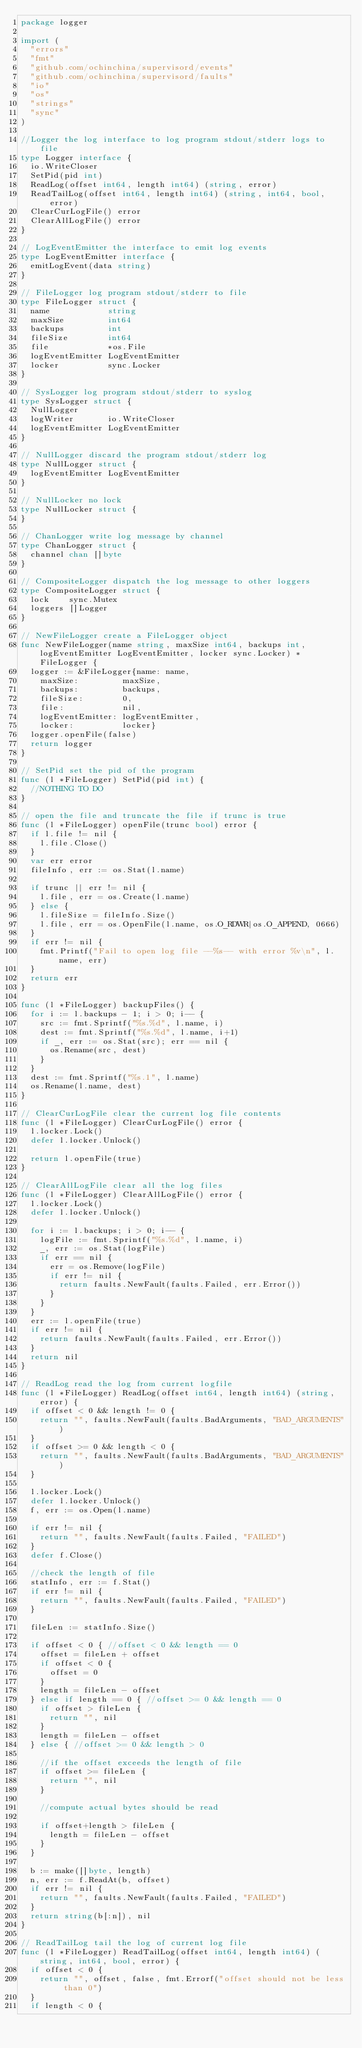Convert code to text. <code><loc_0><loc_0><loc_500><loc_500><_Go_>package logger

import (
	"errors"
	"fmt"
	"github.com/ochinchina/supervisord/events"
	"github.com/ochinchina/supervisord/faults"
	"io"
	"os"
	"strings"
	"sync"
)

//Logger the log interface to log program stdout/stderr logs to file
type Logger interface {
	io.WriteCloser
	SetPid(pid int)
	ReadLog(offset int64, length int64) (string, error)
	ReadTailLog(offset int64, length int64) (string, int64, bool, error)
	ClearCurLogFile() error
	ClearAllLogFile() error
}

// LogEventEmitter the interface to emit log events
type LogEventEmitter interface {
	emitLogEvent(data string)
}

// FileLogger log program stdout/stderr to file
type FileLogger struct {
	name            string
	maxSize         int64
	backups         int
	fileSize        int64
	file            *os.File
	logEventEmitter LogEventEmitter
	locker          sync.Locker
}

// SysLogger log program stdout/stderr to syslog
type SysLogger struct {
	NullLogger
	logWriter       io.WriteCloser
	logEventEmitter LogEventEmitter
}

// NullLogger discard the program stdout/stderr log
type NullLogger struct {
	logEventEmitter LogEventEmitter
}

// NullLocker no lock
type NullLocker struct {
}

// ChanLogger write log message by channel
type ChanLogger struct {
	channel chan []byte
}

// CompositeLogger dispatch the log message to other loggers
type CompositeLogger struct {
	lock    sync.Mutex
	loggers []Logger
}

// NewFileLogger create a FileLogger object
func NewFileLogger(name string, maxSize int64, backups int, logEventEmitter LogEventEmitter, locker sync.Locker) *FileLogger {
	logger := &FileLogger{name: name,
		maxSize:         maxSize,
		backups:         backups,
		fileSize:        0,
		file:            nil,
		logEventEmitter: logEventEmitter,
		locker:          locker}
	logger.openFile(false)
	return logger
}

// SetPid set the pid of the program
func (l *FileLogger) SetPid(pid int) {
	//NOTHING TO DO
}

// open the file and truncate the file if trunc is true
func (l *FileLogger) openFile(trunc bool) error {
	if l.file != nil {
		l.file.Close()
	}
	var err error
	fileInfo, err := os.Stat(l.name)

	if trunc || err != nil {
		l.file, err = os.Create(l.name)
	} else {
		l.fileSize = fileInfo.Size()
		l.file, err = os.OpenFile(l.name, os.O_RDWR|os.O_APPEND, 0666)
	}
	if err != nil {
		fmt.Printf("Fail to open log file --%s-- with error %v\n", l.name, err)
	}
	return err
}

func (l *FileLogger) backupFiles() {
	for i := l.backups - 1; i > 0; i-- {
		src := fmt.Sprintf("%s.%d", l.name, i)
		dest := fmt.Sprintf("%s.%d", l.name, i+1)
		if _, err := os.Stat(src); err == nil {
			os.Rename(src, dest)
		}
	}
	dest := fmt.Sprintf("%s.1", l.name)
	os.Rename(l.name, dest)
}

// ClearCurLogFile clear the current log file contents
func (l *FileLogger) ClearCurLogFile() error {
	l.locker.Lock()
	defer l.locker.Unlock()

	return l.openFile(true)
}

// ClearAllLogFile clear all the log files
func (l *FileLogger) ClearAllLogFile() error {
	l.locker.Lock()
	defer l.locker.Unlock()

	for i := l.backups; i > 0; i-- {
		logFile := fmt.Sprintf("%s.%d", l.name, i)
		_, err := os.Stat(logFile)
		if err == nil {
			err = os.Remove(logFile)
			if err != nil {
				return faults.NewFault(faults.Failed, err.Error())
			}
		}
	}
	err := l.openFile(true)
	if err != nil {
		return faults.NewFault(faults.Failed, err.Error())
	}
	return nil
}

// ReadLog read the log from current logfile
func (l *FileLogger) ReadLog(offset int64, length int64) (string, error) {
	if offset < 0 && length != 0 {
		return "", faults.NewFault(faults.BadArguments, "BAD_ARGUMENTS")
	}
	if offset >= 0 && length < 0 {
		return "", faults.NewFault(faults.BadArguments, "BAD_ARGUMENTS")
	}

	l.locker.Lock()
	defer l.locker.Unlock()
	f, err := os.Open(l.name)

	if err != nil {
		return "", faults.NewFault(faults.Failed, "FAILED")
	}
	defer f.Close()

	//check the length of file
	statInfo, err := f.Stat()
	if err != nil {
		return "", faults.NewFault(faults.Failed, "FAILED")
	}

	fileLen := statInfo.Size()

	if offset < 0 { //offset < 0 && length == 0
		offset = fileLen + offset
		if offset < 0 {
			offset = 0
		}
		length = fileLen - offset
	} else if length == 0 { //offset >= 0 && length == 0
		if offset > fileLen {
			return "", nil
		}
		length = fileLen - offset
	} else { //offset >= 0 && length > 0

		//if the offset exceeds the length of file
		if offset >= fileLen {
			return "", nil
		}

		//compute actual bytes should be read

		if offset+length > fileLen {
			length = fileLen - offset
		}
	}

	b := make([]byte, length)
	n, err := f.ReadAt(b, offset)
	if err != nil {
		return "", faults.NewFault(faults.Failed, "FAILED")
	}
	return string(b[:n]), nil
}

// ReadTailLog tail the log of current log file
func (l *FileLogger) ReadTailLog(offset int64, length int64) (string, int64, bool, error) {
	if offset < 0 {
		return "", offset, false, fmt.Errorf("offset should not be less than 0")
	}
	if length < 0 {</code> 